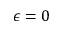Convert formula to latex. <formula><loc_0><loc_0><loc_500><loc_500>\epsilon = 0</formula> 